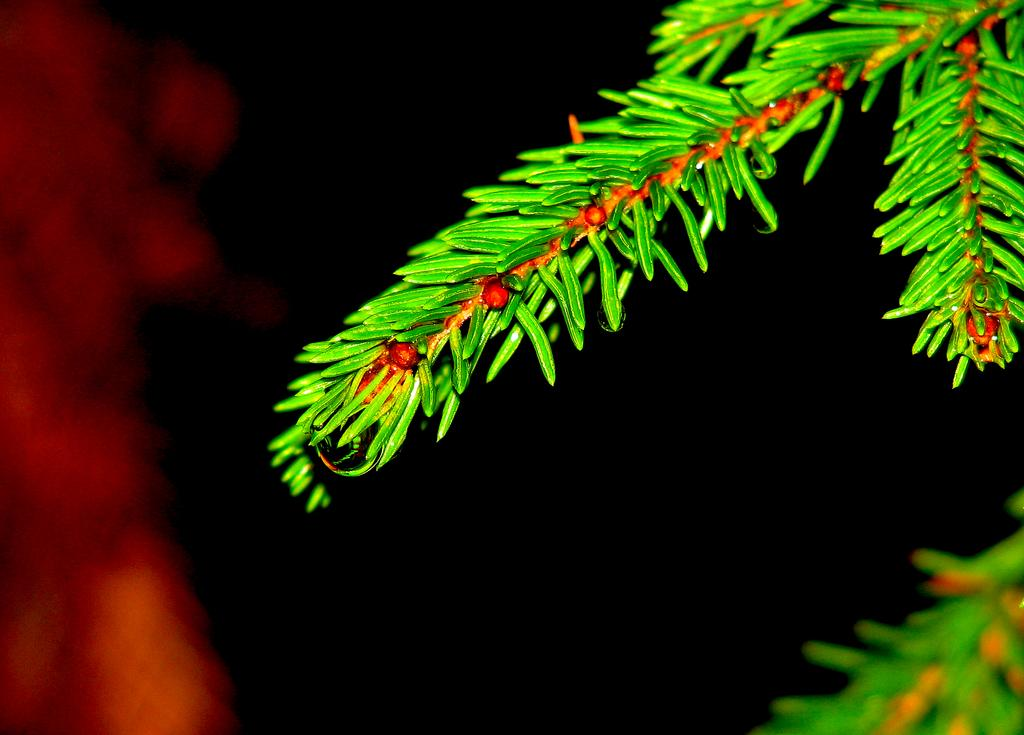What type of tree branch is visible in the image? There is a branch of a Christmas tree in the image. Where is the branch located in the image? The branch is at the top of the image. What type of friction can be observed between the snakes in the image? There are no snakes present in the image, so friction between snakes cannot be observed. 